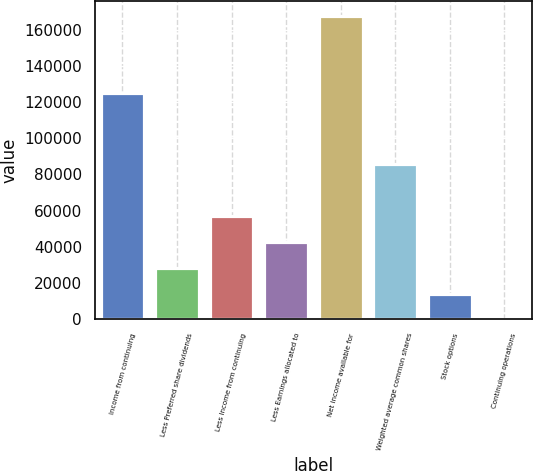<chart> <loc_0><loc_0><loc_500><loc_500><bar_chart><fcel>Income from continuing<fcel>Less Preferred share dividends<fcel>Less Income from continuing<fcel>Less Earnings allocated to<fcel>Net income available for<fcel>Weighted average common shares<fcel>Stock options<fcel>Continuing operations<nl><fcel>124833<fcel>28535.8<fcel>57069.6<fcel>42802.7<fcel>167634<fcel>85603.4<fcel>14268.9<fcel>2<nl></chart> 